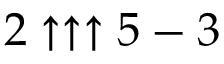<formula> <loc_0><loc_0><loc_500><loc_500>2 \uparrow \uparrow \uparrow 5 - 3</formula> 